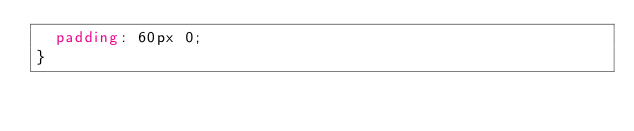<code> <loc_0><loc_0><loc_500><loc_500><_CSS_>  padding: 60px 0;
}
</code> 